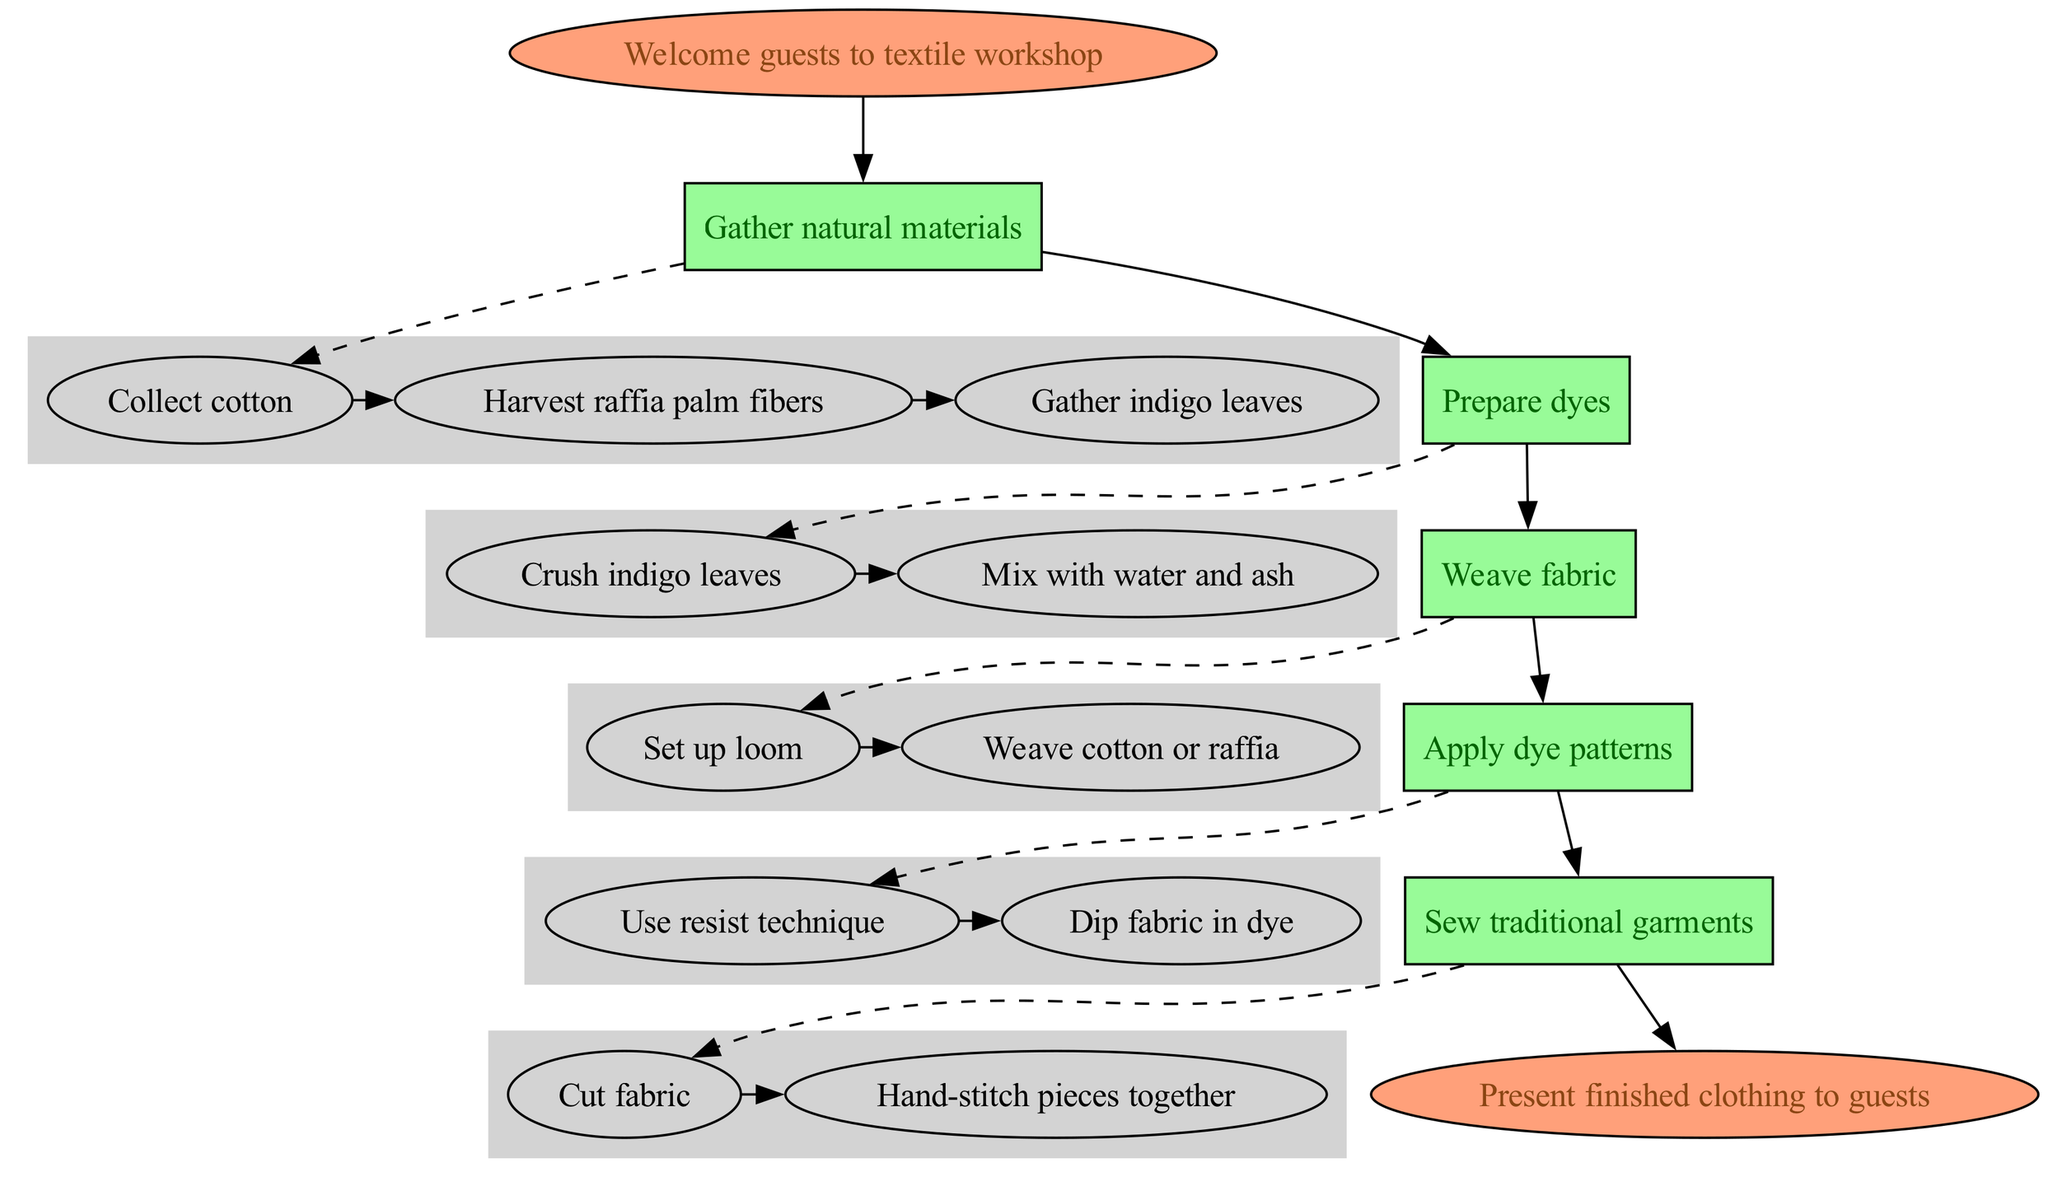What is the first step in the textile creation process? The diagram starts with the "Welcome guests to textile workshop" node, indicating that this is the initial part of the process before any actions are taken.
Answer: Welcome guests to textile workshop How many natural materials are gathered in the process? The first step "Gather natural materials" includes three substeps: "Collect cotton," "Harvest raffia palm fibers," and "Gather indigo leaves." Therefore, three materials are collected.
Answer: 3 What color is the node for "Prepare dyes"? The node representing "Prepare dyes" has a light green color, consistent with the formatting for steps in the diagram.
Answer: Light green Which step comes after "Weave fabric"? The diagram shows an arrow leading from "Weave fabric" to "Apply dye patterns," indicating that the next step in the process follows after weaving.
Answer: Apply dye patterns What technique is used to apply dye patterns? The substep under "Apply dye patterns" states that the "Use resist technique" is employed, which specifies the method used in this stage.
Answer: Use resist technique How many total steps are there before presenting finished clothing? The main steps listed include five distinct actions: "Gather natural materials," "Prepare dyes," "Weave fabric," "Apply dye patterns," and "Sew traditional garments," totaling five steps before reaching the end.
Answer: 5 What is the last node in the diagram? The diagram ends with the node labeled "Present finished clothing to guests," which is the final action after completing all previous steps.
Answer: Present finished clothing to guests What type of structure connects the steps in the process? The nodes are connected by directed edges indicating the flow from one step to the next, forming a clear directional relationship showing progression in the textile creation process.
Answer: Directed edges Which step includes both cutting and hand-stitching? The step labeled "Sew traditional garments" encompasses the substeps of "Cut fabric" and "Hand-stitch pieces together," highlighting these specific actions involved in garment preparation.
Answer: Sew traditional garments 